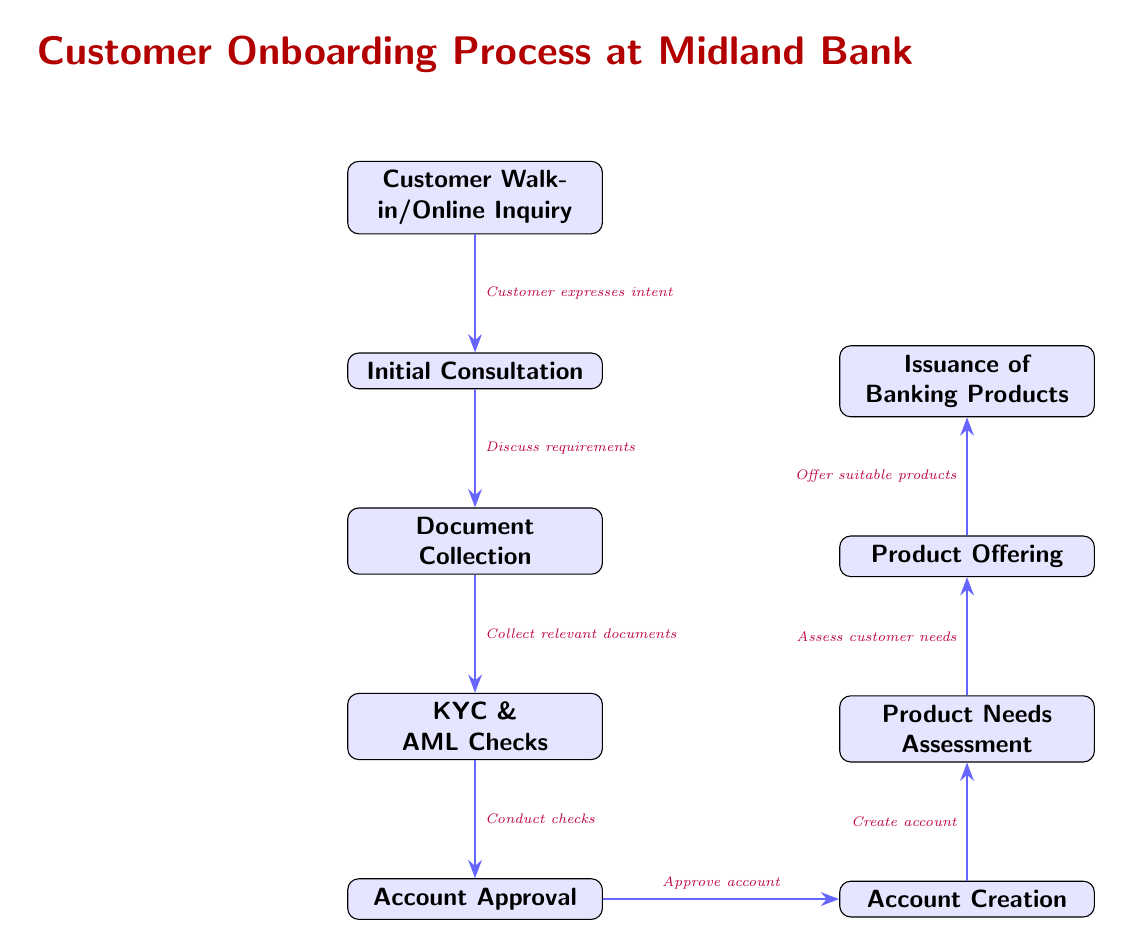What is the first step in the onboarding process? The first step in the onboarding process is represented by node 1, which states "Customer Walk-in/Online Inquiry." This indicates the starting point of the customer engagement with the bank.
Answer: Customer Walk-in/Online Inquiry How many total nodes are there in the diagram? The diagram contains a total of 9 nodes, which include all the steps from the initial inquiry to the issuance of banking products. Counting from node 1 to node 9 gives us nine distinct steps.
Answer: 9 What happens right after document collection? After document collection, the next step is "KYC & AML Checks," which is indicated by the edge following node 3 leading to node 4. This step involves compliance checks before proceeding further.
Answer: KYC & AML Checks Which step comes before account creation? The step that comes before account creation is "Account Approval," represented by node 5. This is crucial as it determines if the customer can proceed to the account creation step.
Answer: Account Approval What action does the bank take after assessing customer needs? After assessing customer needs, the bank offers suitable products, as shown by the transition from node 7 to node 8, illustrating the logical progression after understanding customer requirements.
Answer: Offer suitable products In the diagram, which node is directly linked to "Issuance of Banking Products"? The node directly linked to "Issuance of Banking Products" is "Product Offering," which is node 8. This step is essential in providing the customer with tailored product options before issuing them.
Answer: Product Offering How many edges are there in the diagram? The diagram has 8 edges that connect the 9 nodes, illustrating the flow from one step to the next through the onboarding process clearly.
Answer: 8 Which step follows account approval? "Account Creation" is the step that follows account approval, indicated by the directed edge leading from node 5 to node 6. This is a critical step where the actual customer account is established.
Answer: Account Creation What is the relationship between product needs assessment and product offering? The relationship is sequential, where "Product Needs Assessment" (node 7) is the process of determining what the customer requires before proceeding to "Product Offering" (node 8), showcasing decision-making based on assessment.
Answer: Sequential Relationship 